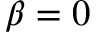<formula> <loc_0><loc_0><loc_500><loc_500>\beta = 0</formula> 